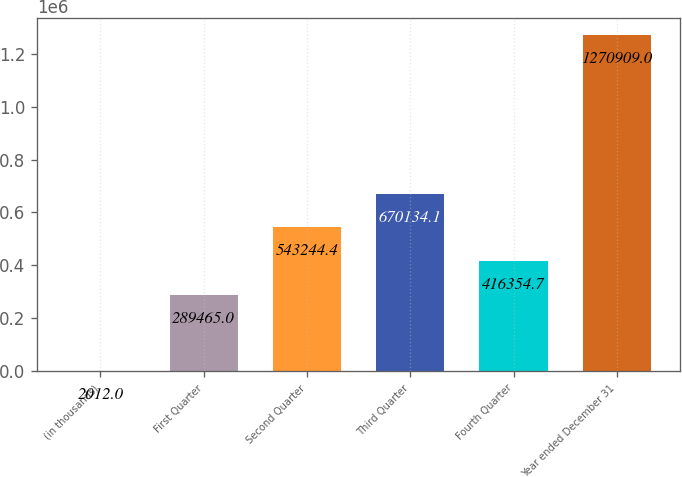<chart> <loc_0><loc_0><loc_500><loc_500><bar_chart><fcel>(in thousands)<fcel>First Quarter<fcel>Second Quarter<fcel>Third Quarter<fcel>Fourth Quarter<fcel>Year ended December 31<nl><fcel>2012<fcel>289465<fcel>543244<fcel>670134<fcel>416355<fcel>1.27091e+06<nl></chart> 